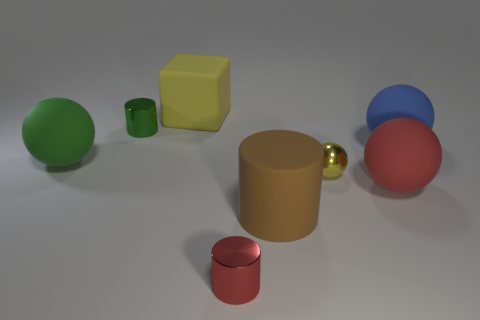Subtract all tiny yellow metallic spheres. How many spheres are left? 3 Add 1 tiny yellow blocks. How many objects exist? 9 Subtract all red cylinders. How many cylinders are left? 2 Subtract 3 cylinders. How many cylinders are left? 0 Subtract all cubes. How many objects are left? 7 Subtract all gray blocks. How many green balls are left? 1 Subtract all blue shiny cubes. Subtract all large yellow matte blocks. How many objects are left? 7 Add 5 big red spheres. How many big red spheres are left? 6 Add 7 tiny red shiny objects. How many tiny red shiny objects exist? 8 Subtract 1 yellow blocks. How many objects are left? 7 